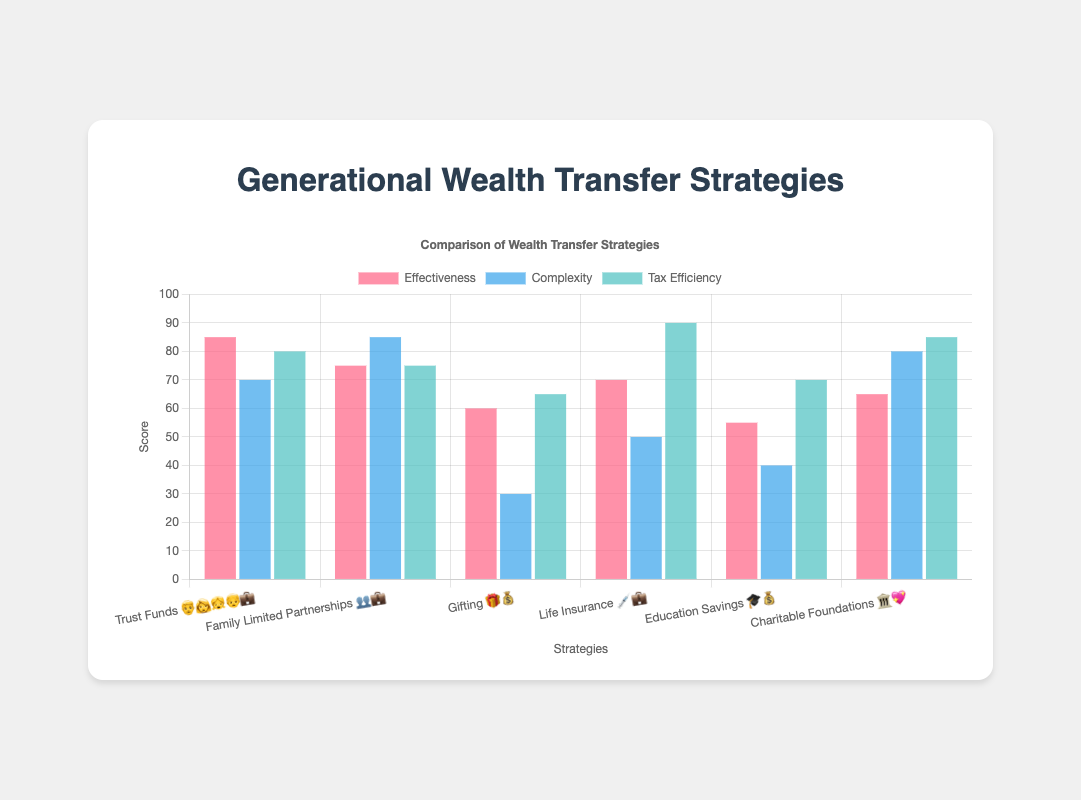What's the most effective wealth transfer strategy based on the chart? The effectiveness scores for each method are shown in the chart. Trust Funds 👨‍👩‍👧‍👦💼 have the highest effectiveness score at 85.
Answer: Trust Funds 👨‍👩‍👧‍👦💼 Which strategy shows the lowest complexity level? The complexity scores are displayed for each method. Gifting 🎁💰 has the lowest complexity score of 30.
Answer: Gifting 🎁💰 How does the tax efficiency of Life Insurance 💉💼 compare to Charitable Foundations 🏛️💖? The tax efficiency scores for Life Insurance 💉💼 and Charitable Foundations 🏛️💖 are 90 and 85, respectively. Life Insurance 💉💼 has a slightly higher tax efficiency.
Answer: Life Insurance 💉💼 is higher Which strategy has the lowest effectiveness score and what is that score? Reviewing the effectiveness scores, Education Savings 🎓💰 has the lowest score, which is 55.
Answer: Education Savings 🎓💰, 55 If you average the complexity score of Trust Funds 👨‍👩‍👧‍👦💼 and Family Limited Partnerships 👥💼, what is the result? The complexity scores are 70 for Trust Funds 👨‍👩‍👧‍👦💼 and 85 for Family Limited Partnerships 👥💼. The average is (70 + 85) / 2 = 77.5.
Answer: 77.5 Which wealth transfer strategy has the highest tax efficiency score? The tax efficiency scores are displayed on the chart. Life Insurance 💉💼 has the highest score of 90.
Answer: Life Insurance 💉💼 Between Trust Funds 👨‍👩‍👧‍👦💼 and Gifting 🎁💰, which method is more complex and by how much? The complexity scores are 70 for Trust Funds 👨‍👩‍👧‍👦💼 and 30 for Gifting 🎁💰. Trust Funds 👨‍👩‍👧‍👦💼 is more complex by 70 - 30 = 40.
Answer: Trust Funds 👨‍👩‍👧‍👦💼, by 40 Identify the strategy with the best overall balance of effectiveness, complexity, and tax efficiency. Life Insurance 💉💼 scores well across the categories: effectiveness (70), complexity (50), and tax efficiency (90), providing a balanced approach.
Answer: Life Insurance 💉💼 What are the common colors used for displaying effectiveness, complexity, and tax efficiency? The chart uses different colors for each category: effectiveness is shown in a shade of red, complexity in a shade of blue, and tax efficiency in a shade of green.
Answer: red, blue, green Which strategy has higher effectiveness than complexity but lower than tax efficiency? Life Insurance 💉💼 has an effectiveness score of 70, a complexity score of 50, and a tax efficiency score of 90.
Answer: Life Insurance 💉💼 